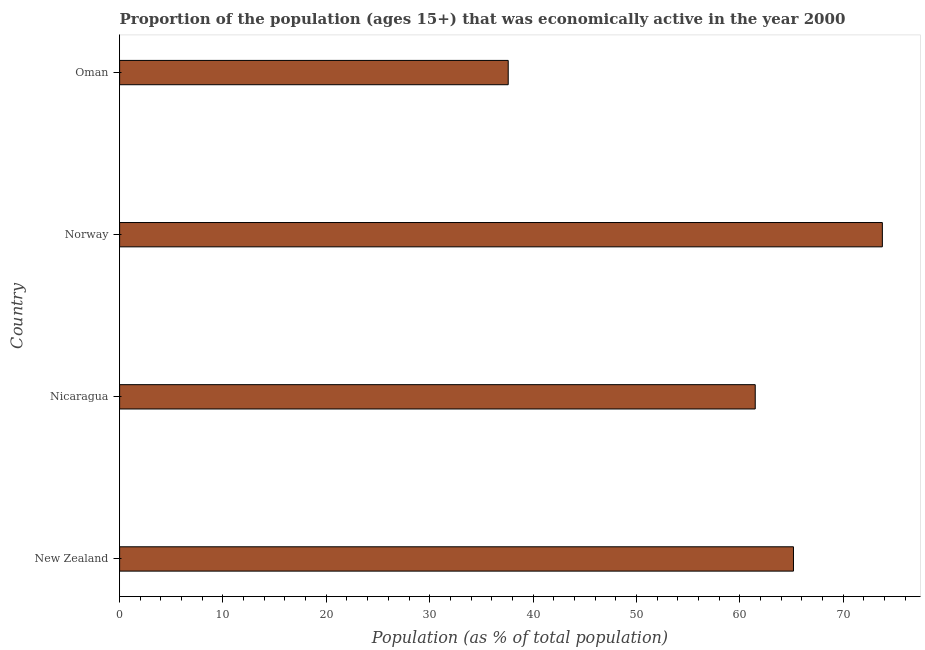What is the title of the graph?
Your answer should be very brief. Proportion of the population (ages 15+) that was economically active in the year 2000. What is the label or title of the X-axis?
Your answer should be very brief. Population (as % of total population). What is the percentage of economically active population in Oman?
Provide a succinct answer. 37.6. Across all countries, what is the maximum percentage of economically active population?
Keep it short and to the point. 73.8. Across all countries, what is the minimum percentage of economically active population?
Your response must be concise. 37.6. In which country was the percentage of economically active population minimum?
Ensure brevity in your answer.  Oman. What is the sum of the percentage of economically active population?
Your answer should be very brief. 238.1. What is the difference between the percentage of economically active population in New Zealand and Oman?
Ensure brevity in your answer.  27.6. What is the average percentage of economically active population per country?
Provide a succinct answer. 59.52. What is the median percentage of economically active population?
Ensure brevity in your answer.  63.35. What is the ratio of the percentage of economically active population in Nicaragua to that in Norway?
Provide a short and direct response. 0.83. Is the percentage of economically active population in Nicaragua less than that in Oman?
Your answer should be very brief. No. Is the difference between the percentage of economically active population in Nicaragua and Oman greater than the difference between any two countries?
Offer a terse response. No. What is the difference between the highest and the second highest percentage of economically active population?
Provide a succinct answer. 8.6. Is the sum of the percentage of economically active population in New Zealand and Norway greater than the maximum percentage of economically active population across all countries?
Offer a terse response. Yes. What is the difference between the highest and the lowest percentage of economically active population?
Give a very brief answer. 36.2. In how many countries, is the percentage of economically active population greater than the average percentage of economically active population taken over all countries?
Make the answer very short. 3. How many bars are there?
Give a very brief answer. 4. How many countries are there in the graph?
Make the answer very short. 4. What is the Population (as % of total population) of New Zealand?
Give a very brief answer. 65.2. What is the Population (as % of total population) in Nicaragua?
Ensure brevity in your answer.  61.5. What is the Population (as % of total population) of Norway?
Offer a terse response. 73.8. What is the Population (as % of total population) of Oman?
Your answer should be very brief. 37.6. What is the difference between the Population (as % of total population) in New Zealand and Norway?
Your response must be concise. -8.6. What is the difference between the Population (as % of total population) in New Zealand and Oman?
Give a very brief answer. 27.6. What is the difference between the Population (as % of total population) in Nicaragua and Norway?
Make the answer very short. -12.3. What is the difference between the Population (as % of total population) in Nicaragua and Oman?
Ensure brevity in your answer.  23.9. What is the difference between the Population (as % of total population) in Norway and Oman?
Provide a short and direct response. 36.2. What is the ratio of the Population (as % of total population) in New Zealand to that in Nicaragua?
Offer a very short reply. 1.06. What is the ratio of the Population (as % of total population) in New Zealand to that in Norway?
Offer a very short reply. 0.88. What is the ratio of the Population (as % of total population) in New Zealand to that in Oman?
Ensure brevity in your answer.  1.73. What is the ratio of the Population (as % of total population) in Nicaragua to that in Norway?
Your answer should be compact. 0.83. What is the ratio of the Population (as % of total population) in Nicaragua to that in Oman?
Provide a short and direct response. 1.64. What is the ratio of the Population (as % of total population) in Norway to that in Oman?
Ensure brevity in your answer.  1.96. 